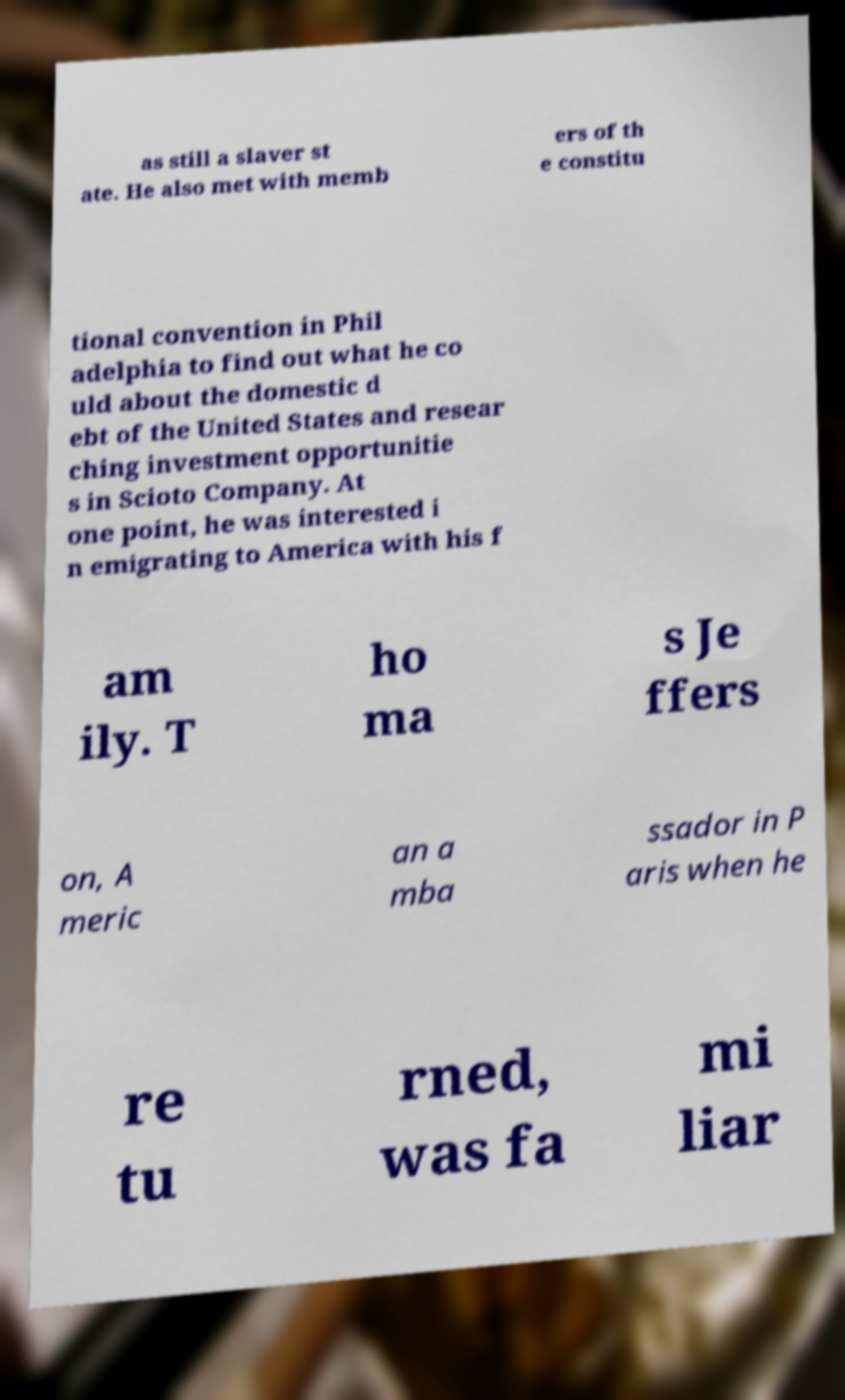Can you read and provide the text displayed in the image?This photo seems to have some interesting text. Can you extract and type it out for me? as still a slaver st ate. He also met with memb ers of th e constitu tional convention in Phil adelphia to find out what he co uld about the domestic d ebt of the United States and resear ching investment opportunitie s in Scioto Company. At one point, he was interested i n emigrating to America with his f am ily. T ho ma s Je ffers on, A meric an a mba ssador in P aris when he re tu rned, was fa mi liar 